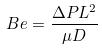<formula> <loc_0><loc_0><loc_500><loc_500>B e = \frac { \Delta P L ^ { 2 } } { \mu D }</formula> 